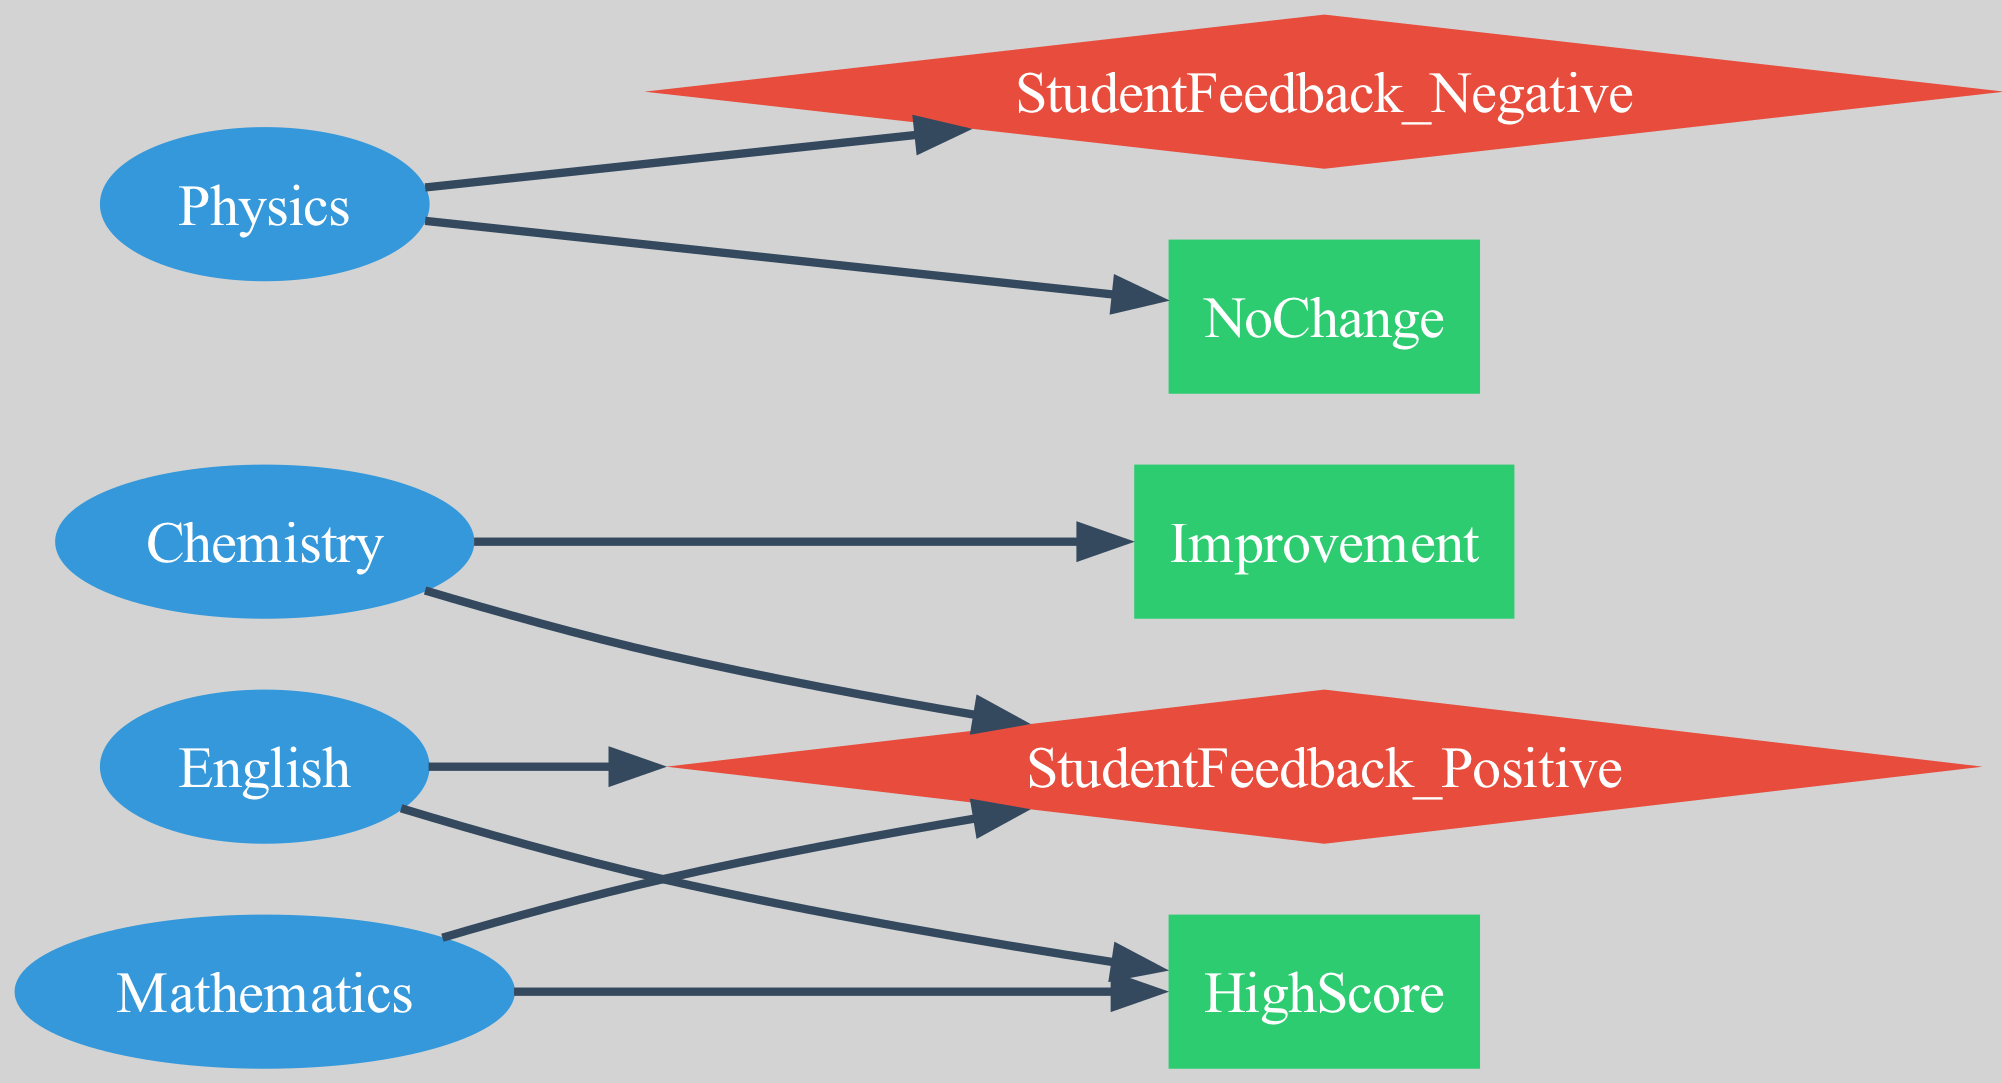What subjects are represented in the diagram? The diagram contains nodes for the subjects: Mathematics, Physics, Chemistry, and English. These can be identified as they are labeled clearly in the node section of the directed graph.
Answer: Mathematics, Physics, Chemistry, English How many feedback nodes are present? There are two feedback nodes: StudentFeedback_Positive and StudentFeedback_Negative. By counting the nodes of type Feedback in the diagram, we arrive at this total.
Answer: 2 Which subject leads to a high score? Mathematics and English are the subjects that connect to the node HighScore based on the directed edges from these subjects in the diagram.
Answer: Mathematics, English What is the outcome for Physics sessions? The outcome for Physics sessions is NoChange, as there is a directed edge from Physics to the NoChange node.
Answer: NoChange Which subject is associated with improvement feedback? Chemistry is associated with the outcome Improvement as indicated by the directed edge from Chemistry to the Improvement node.
Answer: Chemistry What type of relationships does Mathematics have? Mathematics has positive feedback and leads to a high score, as seen from the edges connecting Mathematics to StudentFeedback_Positive and HighScore.
Answer: Positive feedback, High score How many edges are connected to English? English has two connected edges: one leading to StudentFeedback_Positive and another leading to HighScore. Counting these edges gives us the total.
Answer: 2 Are there any negative feedback outcomes linked to Chemistry? No, Chemistry does not connect to any negative feedback nodes. The edges show only positive feedback linked to Chemistry based on the diagram.
Answer: No What is the total number of edges in the diagram? The total number of edges can be found by counting: there are 8 edges connecting the subjects to their respective outcomes or feedback in the directed graph.
Answer: 8 